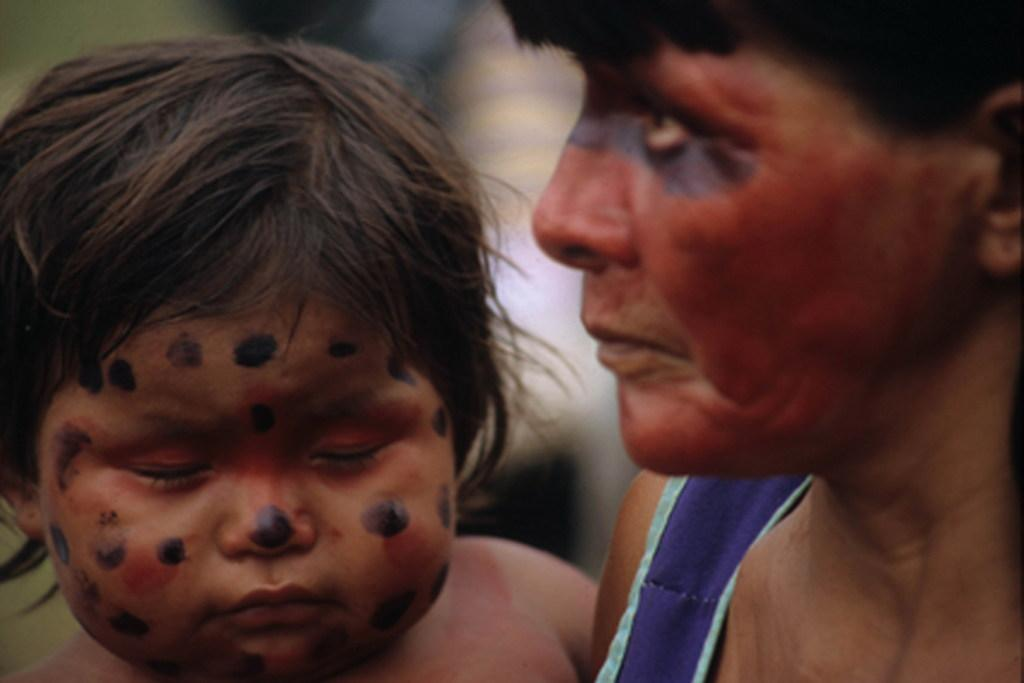How many people are in the image? There are two persons in the image. What is the lady in the image doing? The lady is carrying a baby in the image. What type of chair is the baby sitting on in the image? There is no chair present in the image; the baby is being carried by the lady. Does the lady have a sister in the image? The provided facts do not mention the presence of a sister, so we cannot determine if the lady has a sister in the image. 